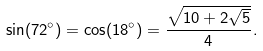Convert formula to latex. <formula><loc_0><loc_0><loc_500><loc_500>\sin ( 7 2 ^ { \circ } ) = \cos ( 1 8 ^ { \circ } ) = { \frac { \sqrt { 1 0 + 2 { \sqrt { 5 } } } } { 4 } } .</formula> 